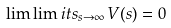Convert formula to latex. <formula><loc_0><loc_0><loc_500><loc_500>\lim \lim i t s _ { s \to \infty } \, V ( s ) = 0</formula> 